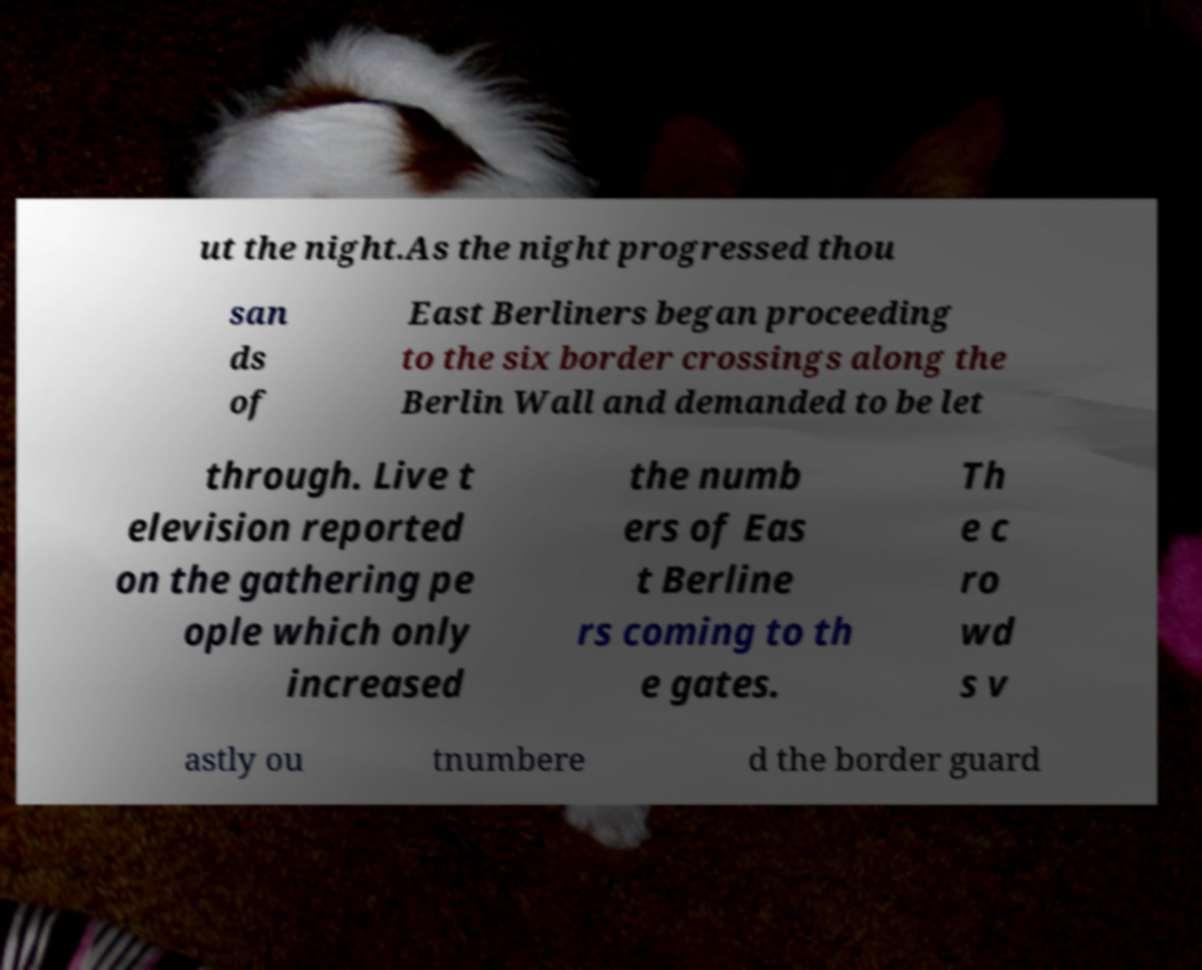There's text embedded in this image that I need extracted. Can you transcribe it verbatim? ut the night.As the night progressed thou san ds of East Berliners began proceeding to the six border crossings along the Berlin Wall and demanded to be let through. Live t elevision reported on the gathering pe ople which only increased the numb ers of Eas t Berline rs coming to th e gates. Th e c ro wd s v astly ou tnumbere d the border guard 